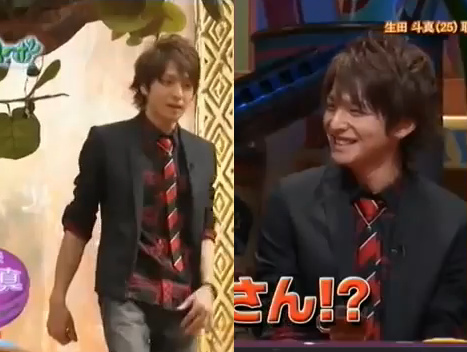Is there an indication of a competition happening? It could be inferred that there is some form of competition happening, given the formal attire and the setting which resembles a stage or studio. The expressions suggest a serious yet engaging environment, typical of competitive or celebratory events. 